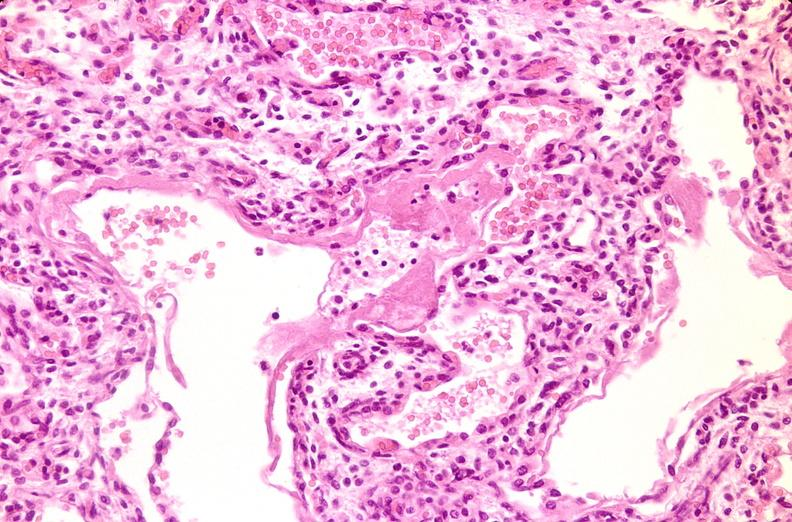what is present?
Answer the question using a single word or phrase. Respiratory 